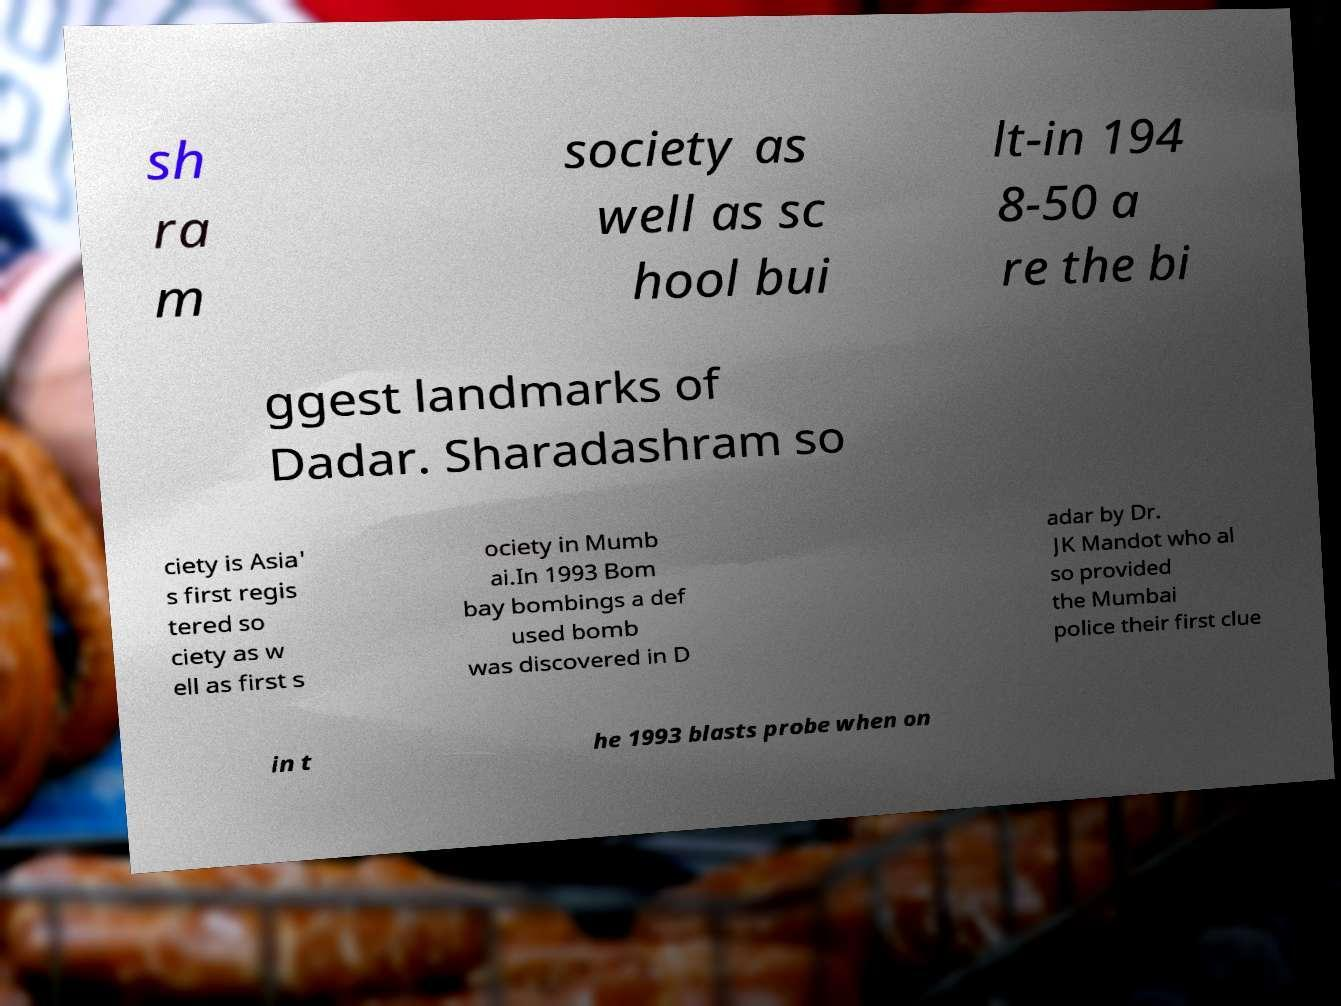Can you accurately transcribe the text from the provided image for me? sh ra m society as well as sc hool bui lt-in 194 8-50 a re the bi ggest landmarks of Dadar. Sharadashram so ciety is Asia' s first regis tered so ciety as w ell as first s ociety in Mumb ai.In 1993 Bom bay bombings a def used bomb was discovered in D adar by Dr. JK Mandot who al so provided the Mumbai police their first clue in t he 1993 blasts probe when on 